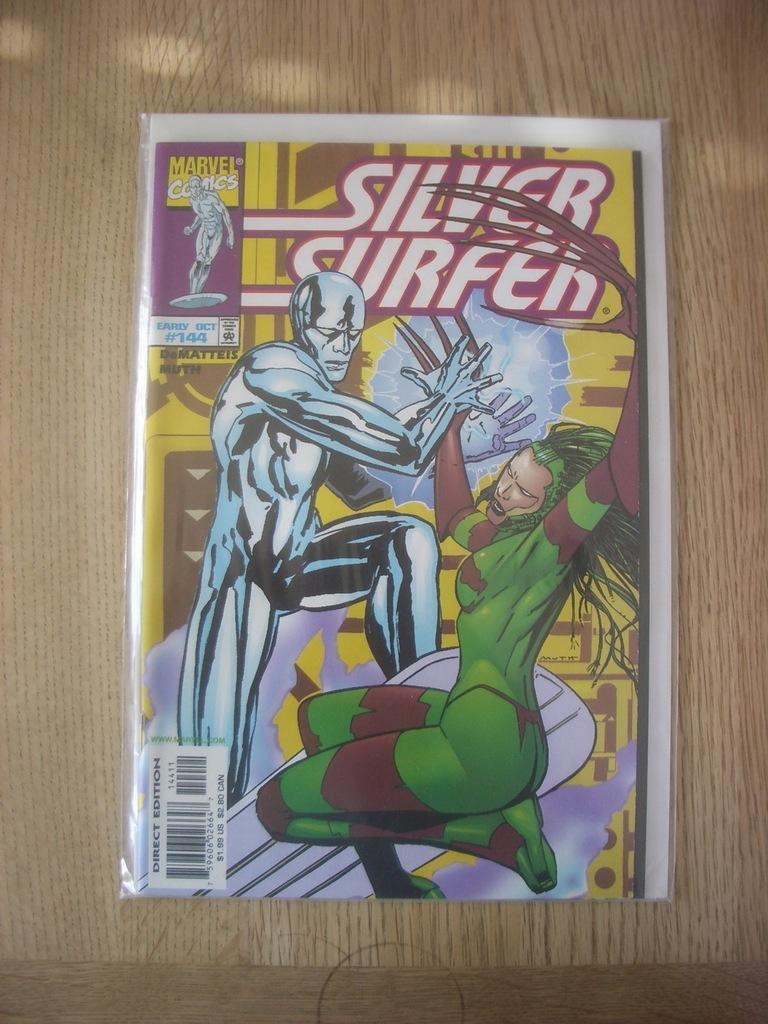Describe this image in one or two sentences. In this image we can see a paper with some animated pictures and a barcode placed on the table. 